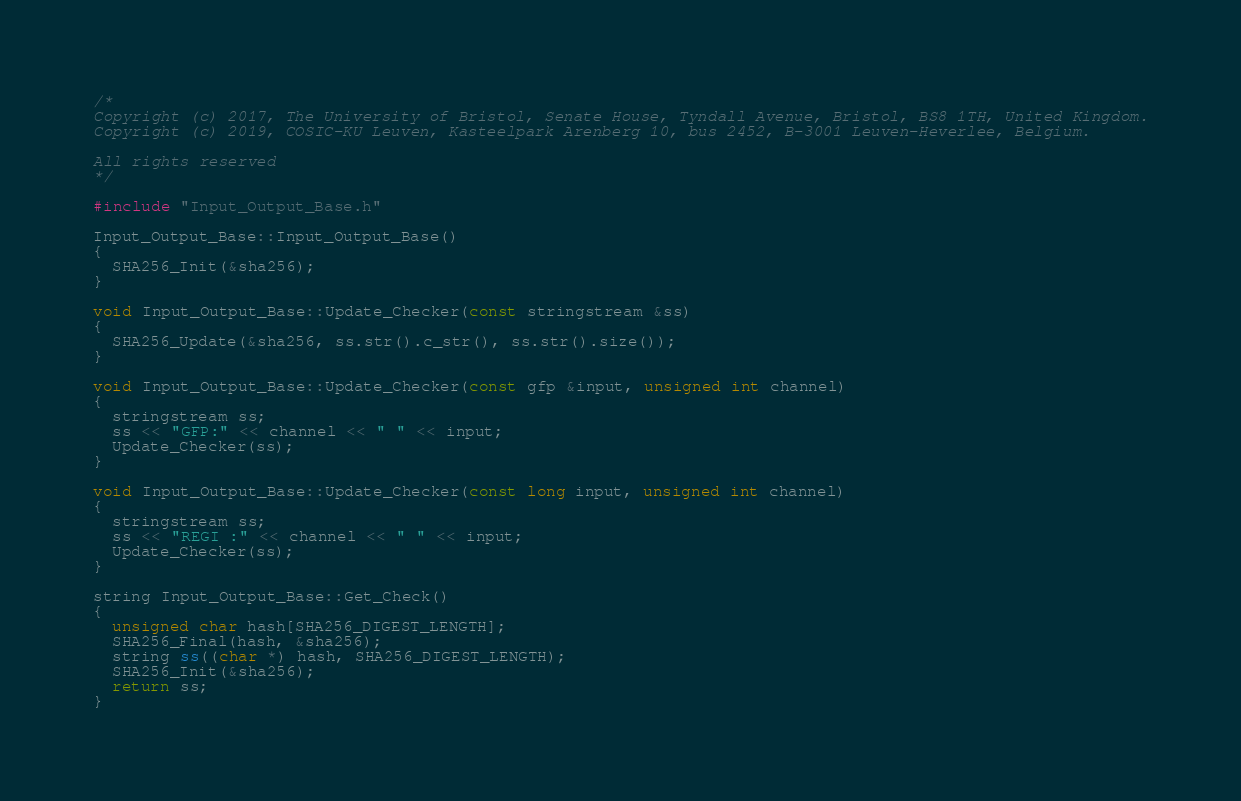<code> <loc_0><loc_0><loc_500><loc_500><_C++_>/*
Copyright (c) 2017, The University of Bristol, Senate House, Tyndall Avenue, Bristol, BS8 1TH, United Kingdom.
Copyright (c) 2019, COSIC-KU Leuven, Kasteelpark Arenberg 10, bus 2452, B-3001 Leuven-Heverlee, Belgium.

All rights reserved
*/

#include "Input_Output_Base.h"

Input_Output_Base::Input_Output_Base()
{
  SHA256_Init(&sha256);
}

void Input_Output_Base::Update_Checker(const stringstream &ss)
{
  SHA256_Update(&sha256, ss.str().c_str(), ss.str().size());
}

void Input_Output_Base::Update_Checker(const gfp &input, unsigned int channel)
{
  stringstream ss;
  ss << "GFP:" << channel << " " << input;
  Update_Checker(ss);
}

void Input_Output_Base::Update_Checker(const long input, unsigned int channel)
{
  stringstream ss;
  ss << "REGI :" << channel << " " << input;
  Update_Checker(ss);
}

string Input_Output_Base::Get_Check()
{
  unsigned char hash[SHA256_DIGEST_LENGTH];
  SHA256_Final(hash, &sha256);
  string ss((char *) hash, SHA256_DIGEST_LENGTH);
  SHA256_Init(&sha256);
  return ss;
}
</code> 